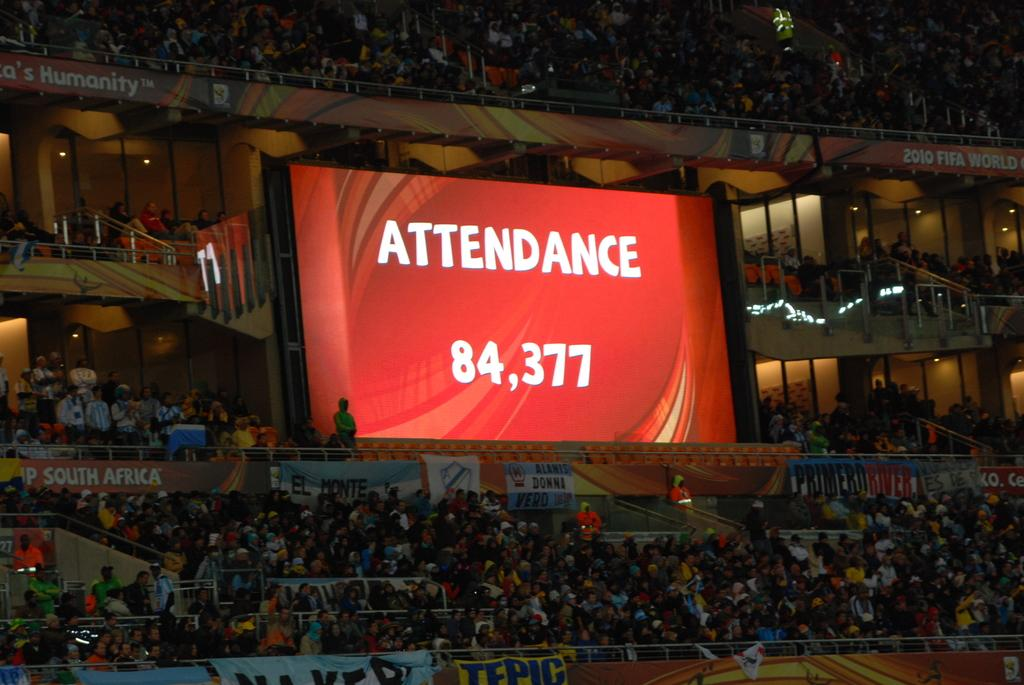What type of structure is depicted in the image? The image contains a stadium. How many people are present in the stadium? The stadium is filled with people. What can be seen on the screen in the stadium? There is text projected on the screen in the stadium. What type of force is being applied to the star in the image? There is no star present in the image, and therefore no force can be applied to it. 